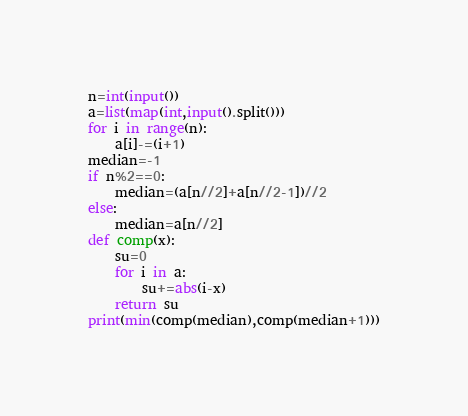<code> <loc_0><loc_0><loc_500><loc_500><_Python_>n=int(input())
a=list(map(int,input().split()))
for i in range(n):
    a[i]-=(i+1)
median=-1
if n%2==0:
    median=(a[n//2]+a[n//2-1])//2
else:
    median=a[n//2]
def comp(x):
    su=0
    for i in a:
        su+=abs(i-x)
    return su
print(min(comp(median),comp(median+1)))



</code> 